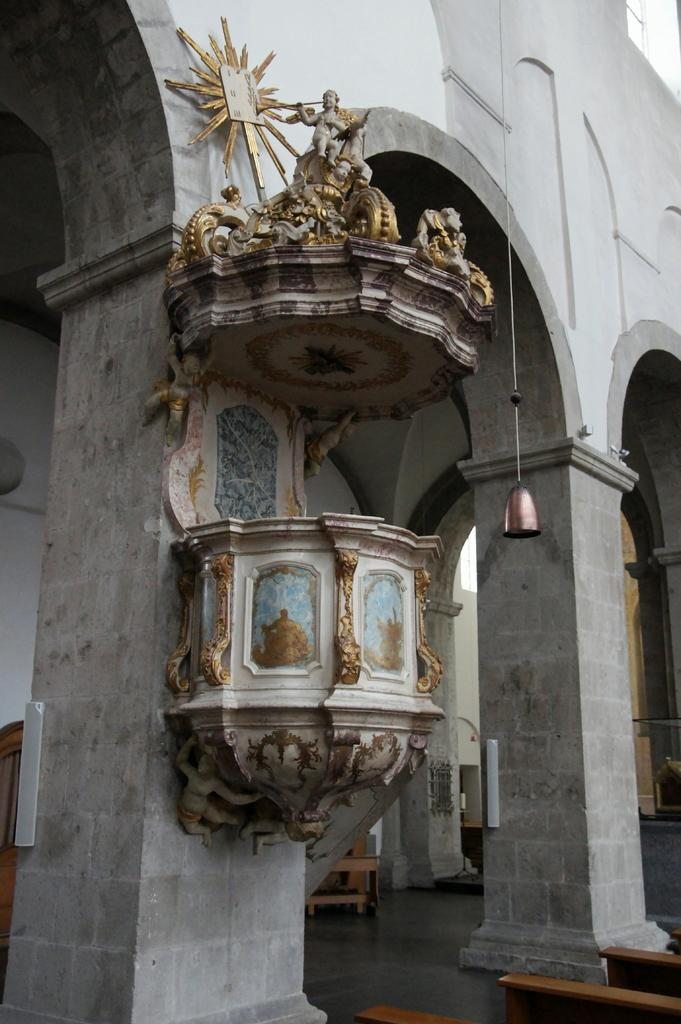What type of structure is visible in the image? There is a building in the image. Are there any other objects or features near the building? Yes, there are statues near the building. Can you describe the appearance of the statues? The statues are in gold and ash colors. What type of seating is available in the image? There are benches on the floor in the image. Can you hear the band playing in the image? There is no band present in the image, so it is not possible to hear them playing. 